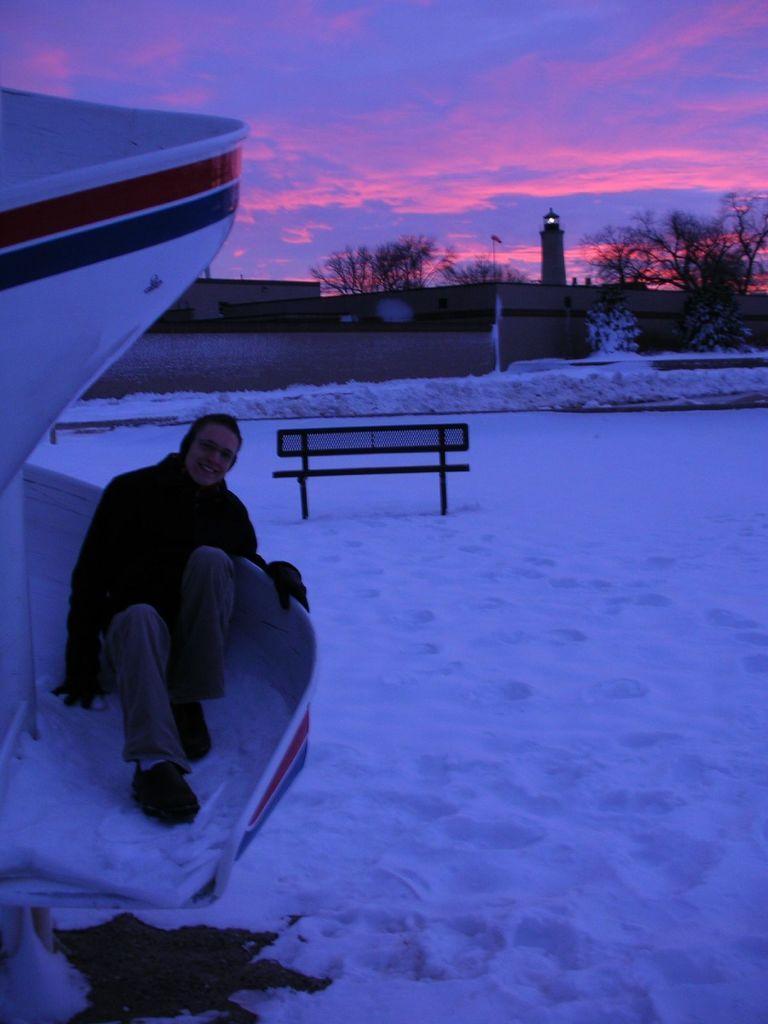In one or two sentences, can you explain what this image depicts? In this image, we can see a person on the slide. We can see the ground covered with snow, a bench. We can also see a lighthouse, a few trees. We can see the wall and the sky with clouds. 